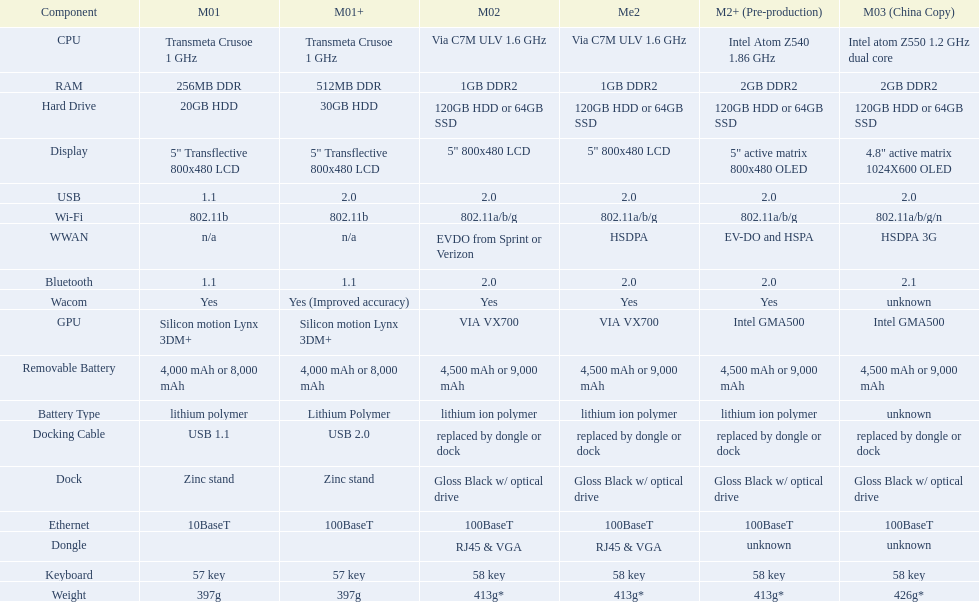Can one identify a minimum of 13 distinct elements on the graph? Yes. 